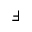Convert formula to latex. <formula><loc_0><loc_0><loc_500><loc_500>\Finv</formula> 